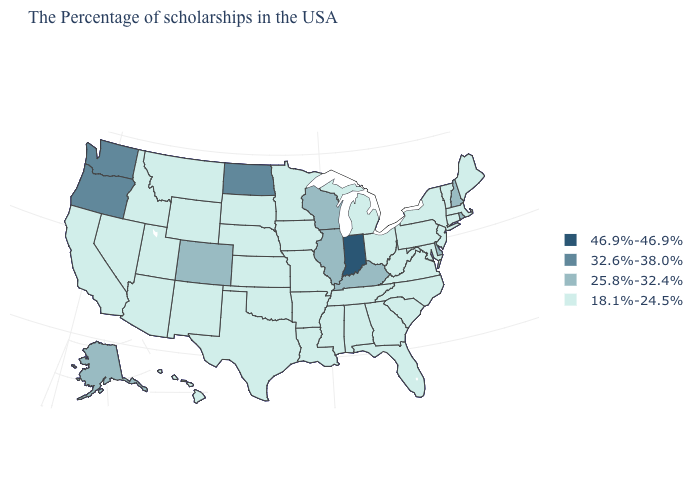Does Washington have the highest value in the West?
Give a very brief answer. Yes. What is the value of Maine?
Keep it brief. 18.1%-24.5%. Which states have the lowest value in the USA?
Give a very brief answer. Maine, Massachusetts, Vermont, Connecticut, New York, New Jersey, Maryland, Pennsylvania, Virginia, North Carolina, South Carolina, West Virginia, Ohio, Florida, Georgia, Michigan, Alabama, Tennessee, Mississippi, Louisiana, Missouri, Arkansas, Minnesota, Iowa, Kansas, Nebraska, Oklahoma, Texas, South Dakota, Wyoming, New Mexico, Utah, Montana, Arizona, Idaho, Nevada, California, Hawaii. What is the lowest value in the Northeast?
Answer briefly. 18.1%-24.5%. Name the states that have a value in the range 18.1%-24.5%?
Write a very short answer. Maine, Massachusetts, Vermont, Connecticut, New York, New Jersey, Maryland, Pennsylvania, Virginia, North Carolina, South Carolina, West Virginia, Ohio, Florida, Georgia, Michigan, Alabama, Tennessee, Mississippi, Louisiana, Missouri, Arkansas, Minnesota, Iowa, Kansas, Nebraska, Oklahoma, Texas, South Dakota, Wyoming, New Mexico, Utah, Montana, Arizona, Idaho, Nevada, California, Hawaii. Does Delaware have the highest value in the USA?
Concise answer only. No. Is the legend a continuous bar?
Concise answer only. No. Among the states that border New Hampshire , which have the lowest value?
Quick response, please. Maine, Massachusetts, Vermont. What is the value of Montana?
Give a very brief answer. 18.1%-24.5%. Does Alaska have the lowest value in the West?
Concise answer only. No. Is the legend a continuous bar?
Quick response, please. No. What is the value of Arizona?
Concise answer only. 18.1%-24.5%. Name the states that have a value in the range 46.9%-46.9%?
Give a very brief answer. Indiana. What is the highest value in states that border Louisiana?
Answer briefly. 18.1%-24.5%. What is the value of Iowa?
Give a very brief answer. 18.1%-24.5%. 